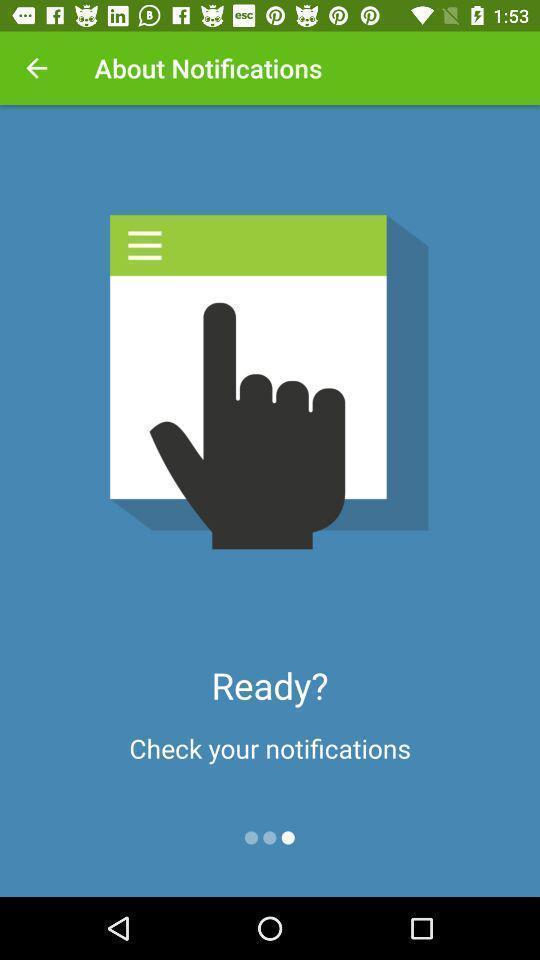Give me a summary of this screen capture. Page shows to check your notifications. 